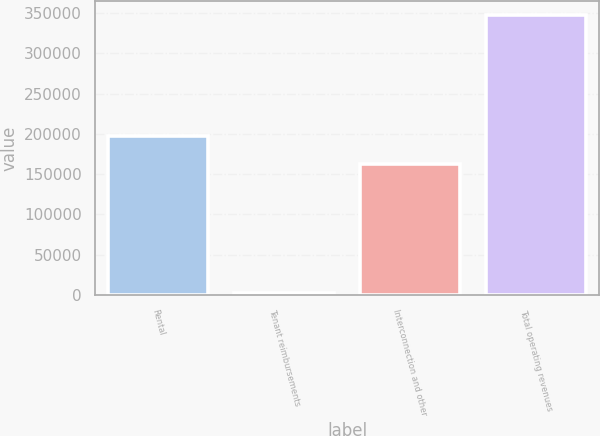<chart> <loc_0><loc_0><loc_500><loc_500><bar_chart><fcel>Rental<fcel>Tenant reimbursements<fcel>Interconnection and other<fcel>Total operating revenues<nl><fcel>196788<fcel>3010<fcel>162306<fcel>347835<nl></chart> 